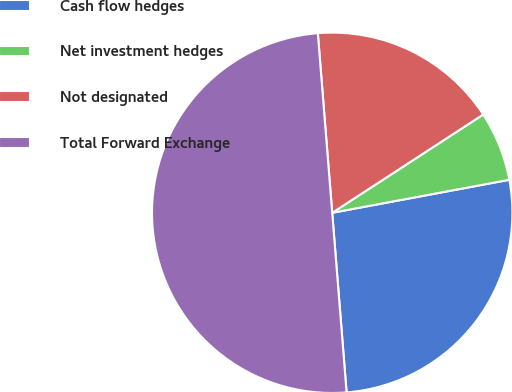Convert chart to OTSL. <chart><loc_0><loc_0><loc_500><loc_500><pie_chart><fcel>Cash flow hedges<fcel>Net investment hedges<fcel>Not designated<fcel>Total Forward Exchange<nl><fcel>26.66%<fcel>6.25%<fcel>17.09%<fcel>50.0%<nl></chart> 